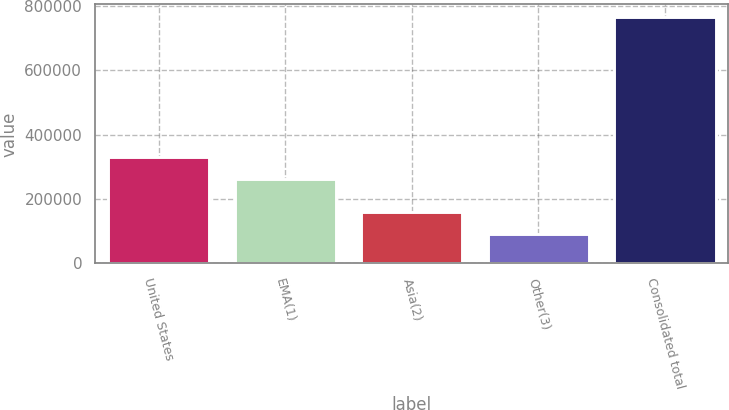Convert chart. <chart><loc_0><loc_0><loc_500><loc_500><bar_chart><fcel>United States<fcel>EMA(1)<fcel>Asia(2)<fcel>Other(3)<fcel>Consolidated total<nl><fcel>329660<fcel>262083<fcel>159669<fcel>92092<fcel>767858<nl></chart> 